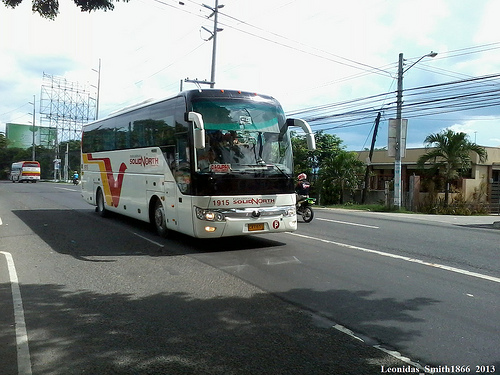Please provide a short description for this region: [0.82, 0.36, 0.97, 0.63]. A tall palm tree standing near a building. 